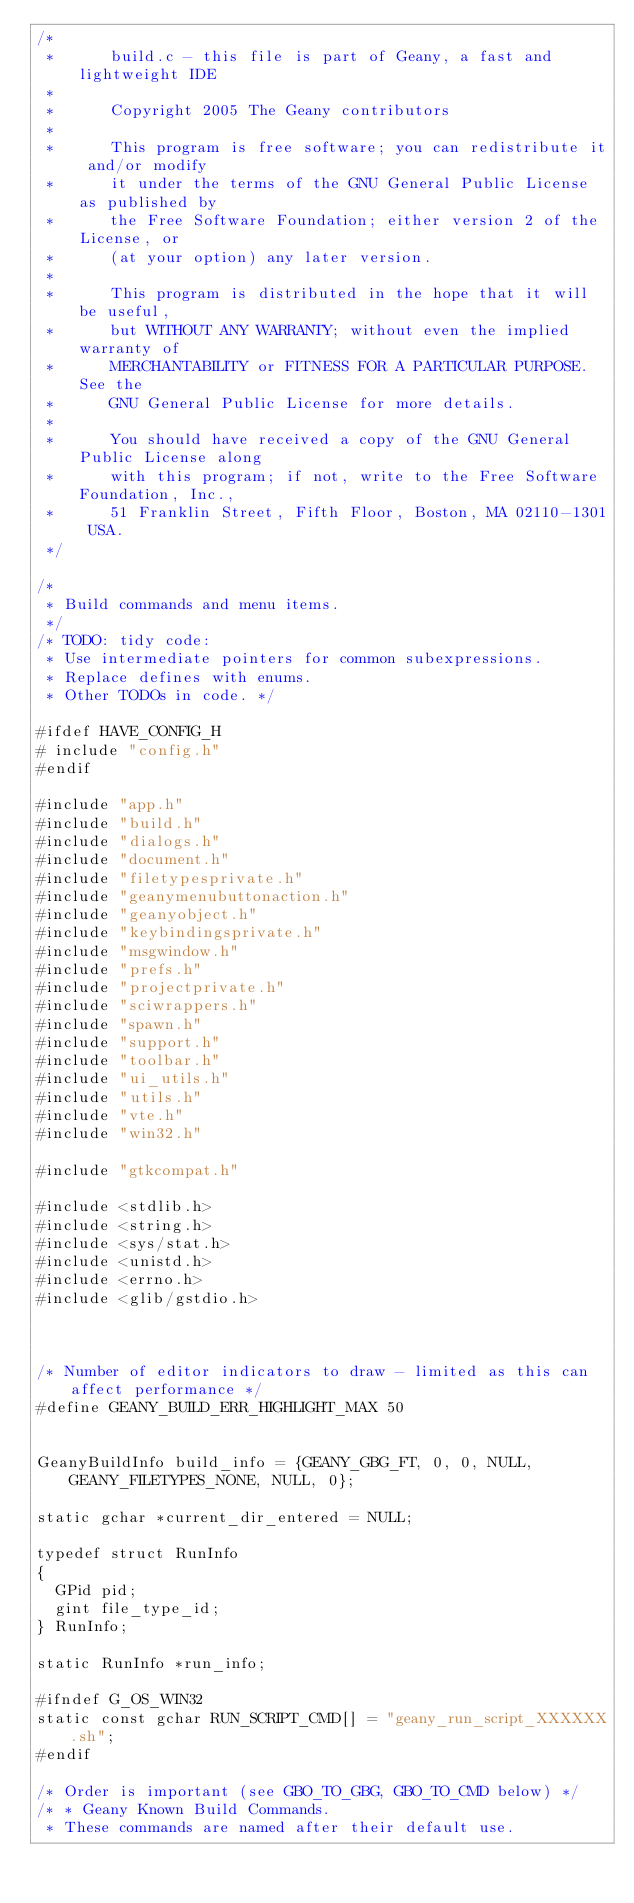<code> <loc_0><loc_0><loc_500><loc_500><_C_>/*
 *      build.c - this file is part of Geany, a fast and lightweight IDE
 *
 *      Copyright 2005 The Geany contributors
 *
 *      This program is free software; you can redistribute it and/or modify
 *      it under the terms of the GNU General Public License as published by
 *      the Free Software Foundation; either version 2 of the License, or
 *      (at your option) any later version.
 *
 *      This program is distributed in the hope that it will be useful,
 *      but WITHOUT ANY WARRANTY; without even the implied warranty of
 *      MERCHANTABILITY or FITNESS FOR A PARTICULAR PURPOSE.  See the
 *      GNU General Public License for more details.
 *
 *      You should have received a copy of the GNU General Public License along
 *      with this program; if not, write to the Free Software Foundation, Inc.,
 *      51 Franklin Street, Fifth Floor, Boston, MA 02110-1301 USA.
 */

/*
 * Build commands and menu items.
 */
/* TODO: tidy code:
 * Use intermediate pointers for common subexpressions.
 * Replace defines with enums.
 * Other TODOs in code. */

#ifdef HAVE_CONFIG_H
# include "config.h"
#endif

#include "app.h"
#include "build.h"
#include "dialogs.h"
#include "document.h"
#include "filetypesprivate.h"
#include "geanymenubuttonaction.h"
#include "geanyobject.h"
#include "keybindingsprivate.h"
#include "msgwindow.h"
#include "prefs.h"
#include "projectprivate.h"
#include "sciwrappers.h"
#include "spawn.h"
#include "support.h"
#include "toolbar.h"
#include "ui_utils.h"
#include "utils.h"
#include "vte.h"
#include "win32.h"

#include "gtkcompat.h"

#include <stdlib.h>
#include <string.h>
#include <sys/stat.h>
#include <unistd.h>
#include <errno.h>
#include <glib/gstdio.h>



/* Number of editor indicators to draw - limited as this can affect performance */
#define GEANY_BUILD_ERR_HIGHLIGHT_MAX 50


GeanyBuildInfo build_info = {GEANY_GBG_FT, 0, 0, NULL, GEANY_FILETYPES_NONE, NULL, 0};

static gchar *current_dir_entered = NULL;

typedef struct RunInfo
{
	GPid pid;
	gint file_type_id;
} RunInfo;

static RunInfo *run_info;

#ifndef G_OS_WIN32
static const gchar RUN_SCRIPT_CMD[] = "geany_run_script_XXXXXX.sh";
#endif

/* Order is important (see GBO_TO_GBG, GBO_TO_CMD below) */
/* * Geany Known Build Commands.
 * These commands are named after their default use.</code> 